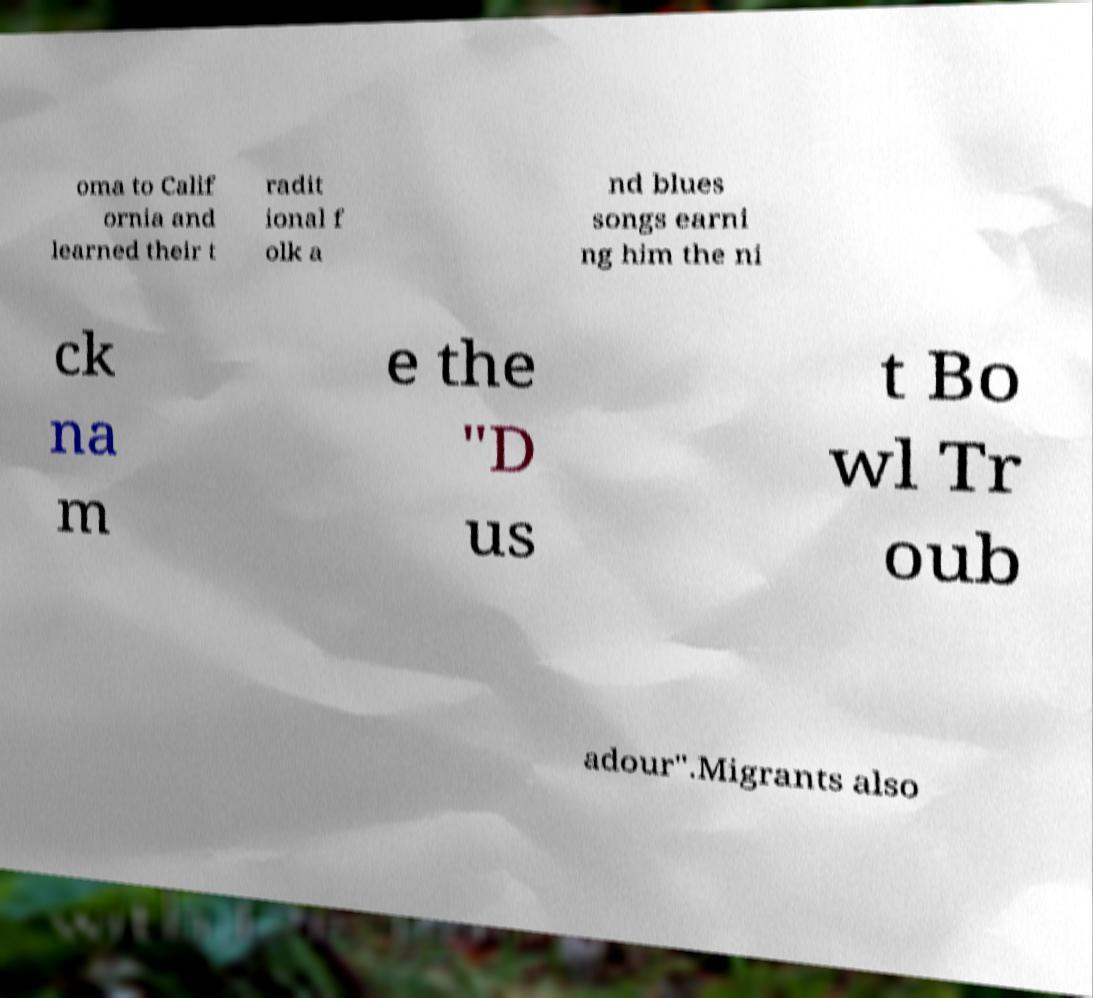Please identify and transcribe the text found in this image. oma to Calif ornia and learned their t radit ional f olk a nd blues songs earni ng him the ni ck na m e the "D us t Bo wl Tr oub adour".Migrants also 